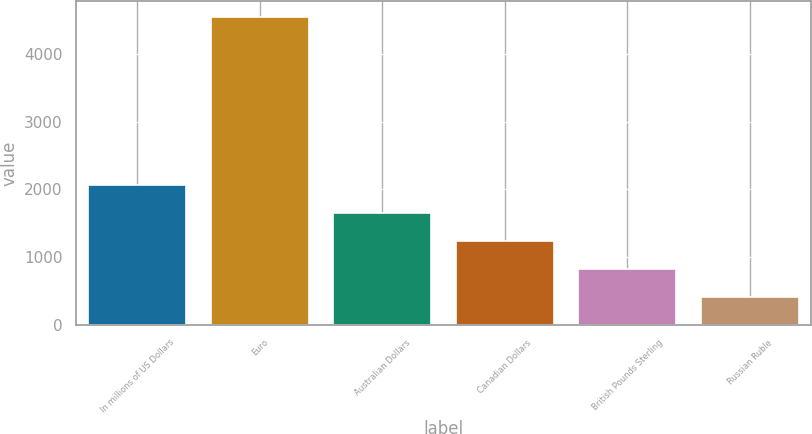<chart> <loc_0><loc_0><loc_500><loc_500><bar_chart><fcel>In millions of US Dollars<fcel>Euro<fcel>Australian Dollars<fcel>Canadian Dollars<fcel>British Pounds Sterling<fcel>Russian Ruble<nl><fcel>2064.6<fcel>4551<fcel>1650.2<fcel>1235.8<fcel>821.4<fcel>407<nl></chart> 